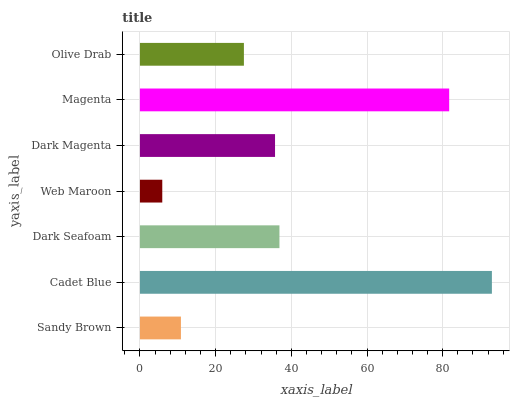Is Web Maroon the minimum?
Answer yes or no. Yes. Is Cadet Blue the maximum?
Answer yes or no. Yes. Is Dark Seafoam the minimum?
Answer yes or no. No. Is Dark Seafoam the maximum?
Answer yes or no. No. Is Cadet Blue greater than Dark Seafoam?
Answer yes or no. Yes. Is Dark Seafoam less than Cadet Blue?
Answer yes or no. Yes. Is Dark Seafoam greater than Cadet Blue?
Answer yes or no. No. Is Cadet Blue less than Dark Seafoam?
Answer yes or no. No. Is Dark Magenta the high median?
Answer yes or no. Yes. Is Dark Magenta the low median?
Answer yes or no. Yes. Is Magenta the high median?
Answer yes or no. No. Is Olive Drab the low median?
Answer yes or no. No. 